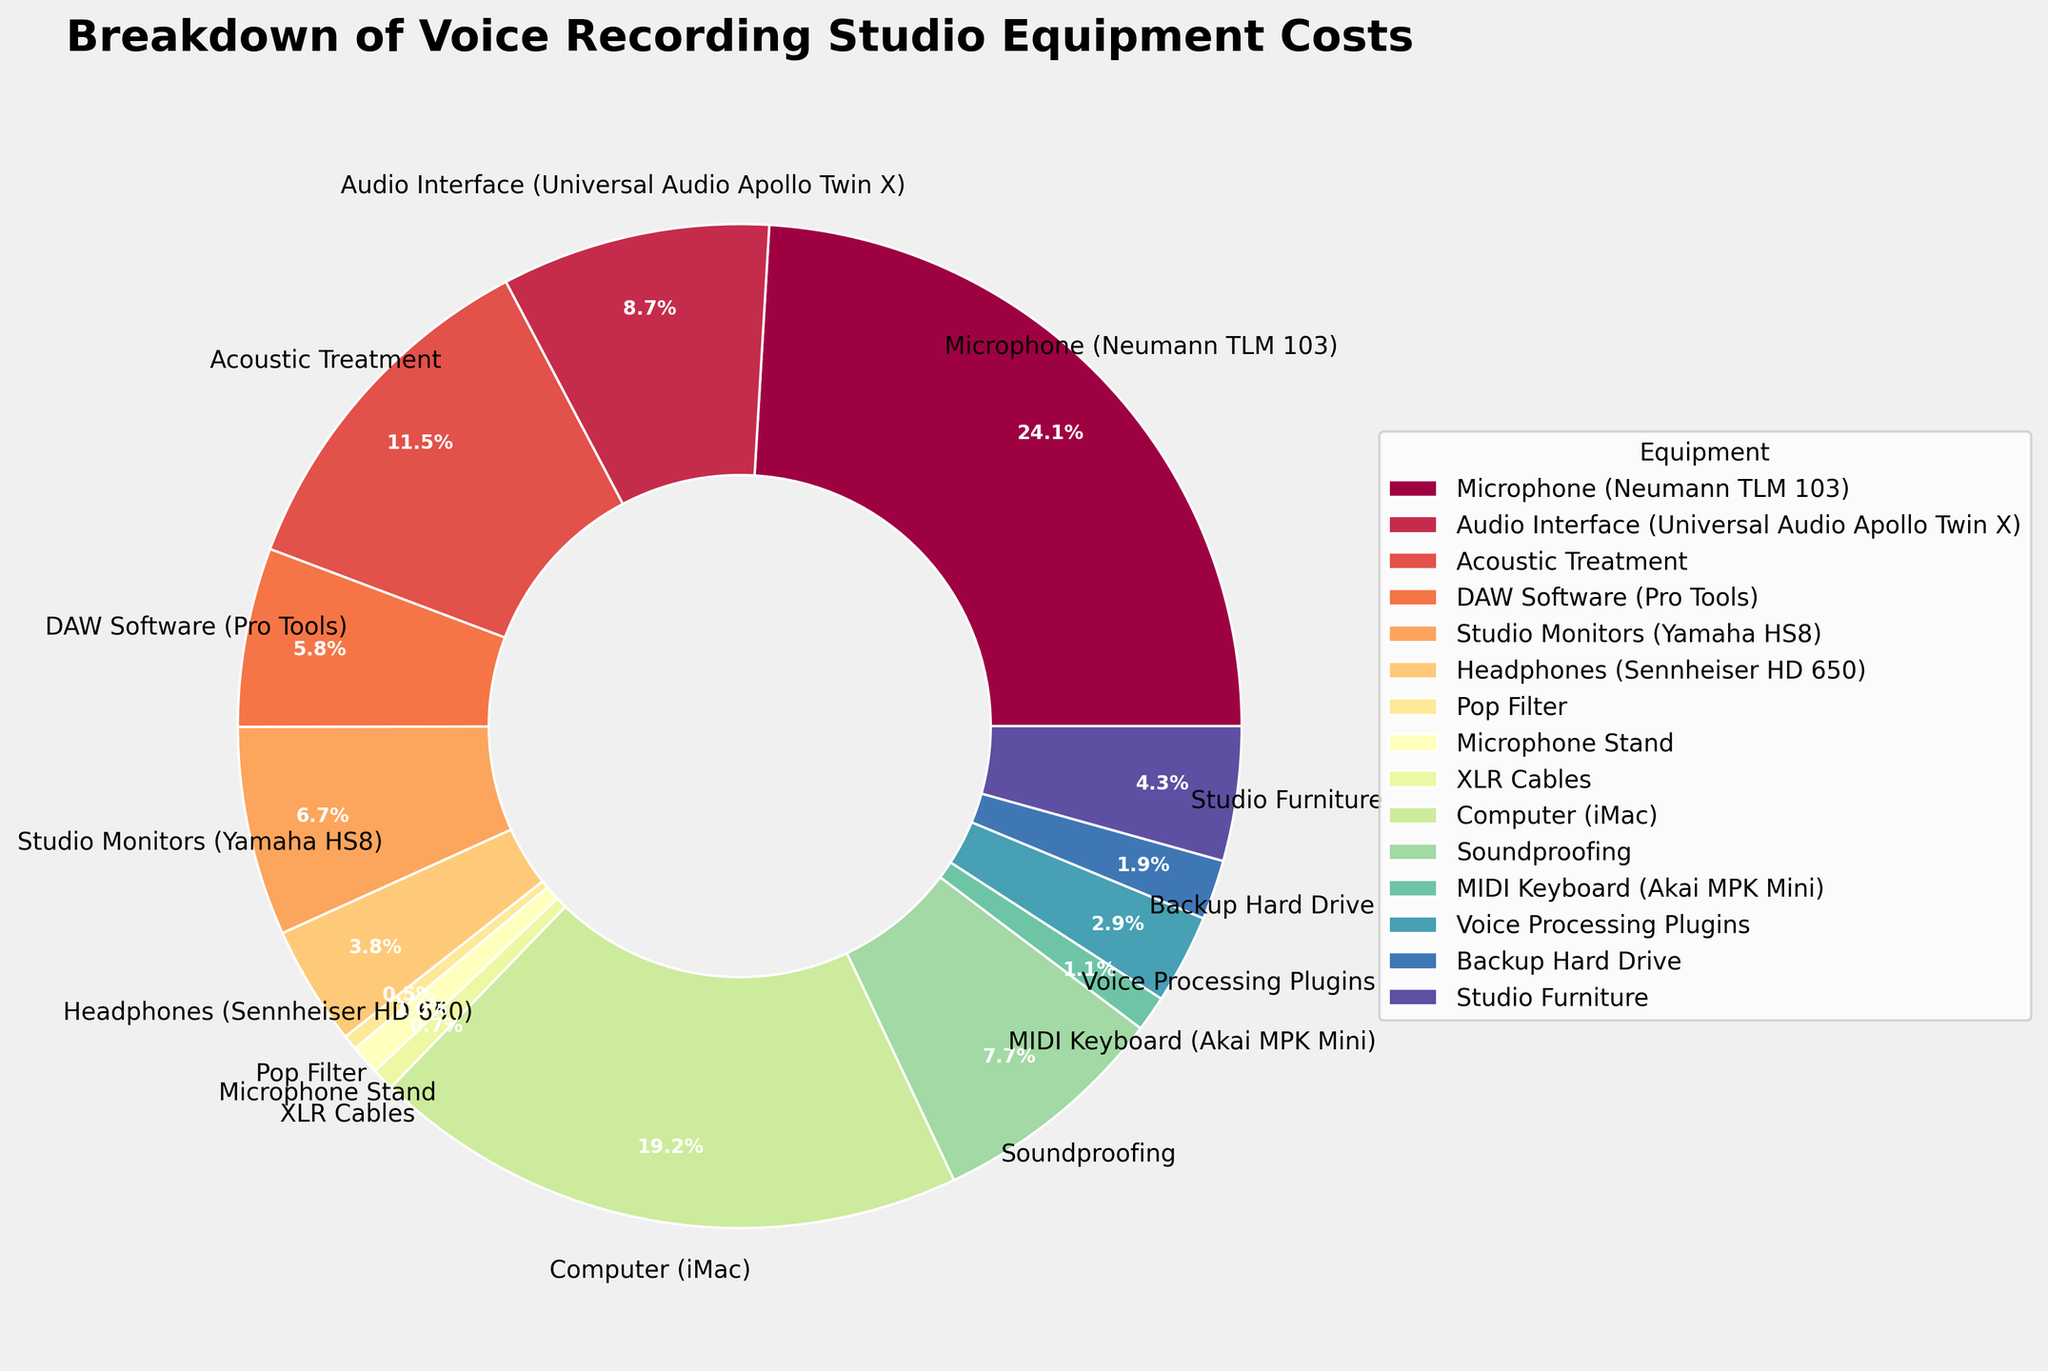What's the top three expensive equipment based on the share of the total cost? First, identify the wedges in the pie chart that represent the largest proportions. Then check the labels for these wedges. The top three should stand out due to their significantly larger size.
Answer: Microphone (Neumann TLM 103), Computer (iMac), and Acoustic Treatment What percentage of the total cost is attributed to Soundproofing and Studio Furniture combined? Locate the segments for Soundproofing and Studio Furniture in the pie chart. Add the percentages of these two segments together.
Answer: 10.08% Which equipment has the smallest cost share in the pie chart? Identify the wedge in the pie chart that is smallest in size, which indicates the smallest cost. Check the label for this wedge.
Answer: Pop Filter Is the cost of the Computer (iMac) greater than the combined cost of the DAW Software (Pro Tools) and Audio Interface (Universal Audio Apollo Twin X)? First, compare the wedge sizes for the Computer and the combined wedges of DAW Software and Audio Interface. Then sum the percentages of DAW Software and Audio Interface and compare with that of the Computer.
Answer: Yes Are the costs for Studio Monitors and MIDI Keyboard greater than the cost of Acoustic Treatment? Compare the combined wedge sizes of Studio Monitors and MIDI Keyboard with the wedge size of Acoustic Treatment. Verify by summing the individual percentages of Studio Monitors and MIDI Keyboard and comparing to Acoustic Treatment’s percentage.
Answer: No What is the combined percentage of costs attributed to the Microphone Stand and XLR Cables? Identify the wedges for Microphone Stand and XLR Cables. Sum up their percentages.
Answer: 1.42% Which equipment category has a larger cost proportion: Audio Interface or Studio Monitors? Compare the sizes of the wedges representing the Audio Interface and Studio Monitors. The larger wedge corresponds to the larger cost share.
Answer: Audio Interface How many pieces of equipment have a cost share of exactly less than 5%? Locate and count all the wedges that indicate a cost proportion less than 5% by checking their labels and corresponding percentages in the pie chart.
Answer: 11 